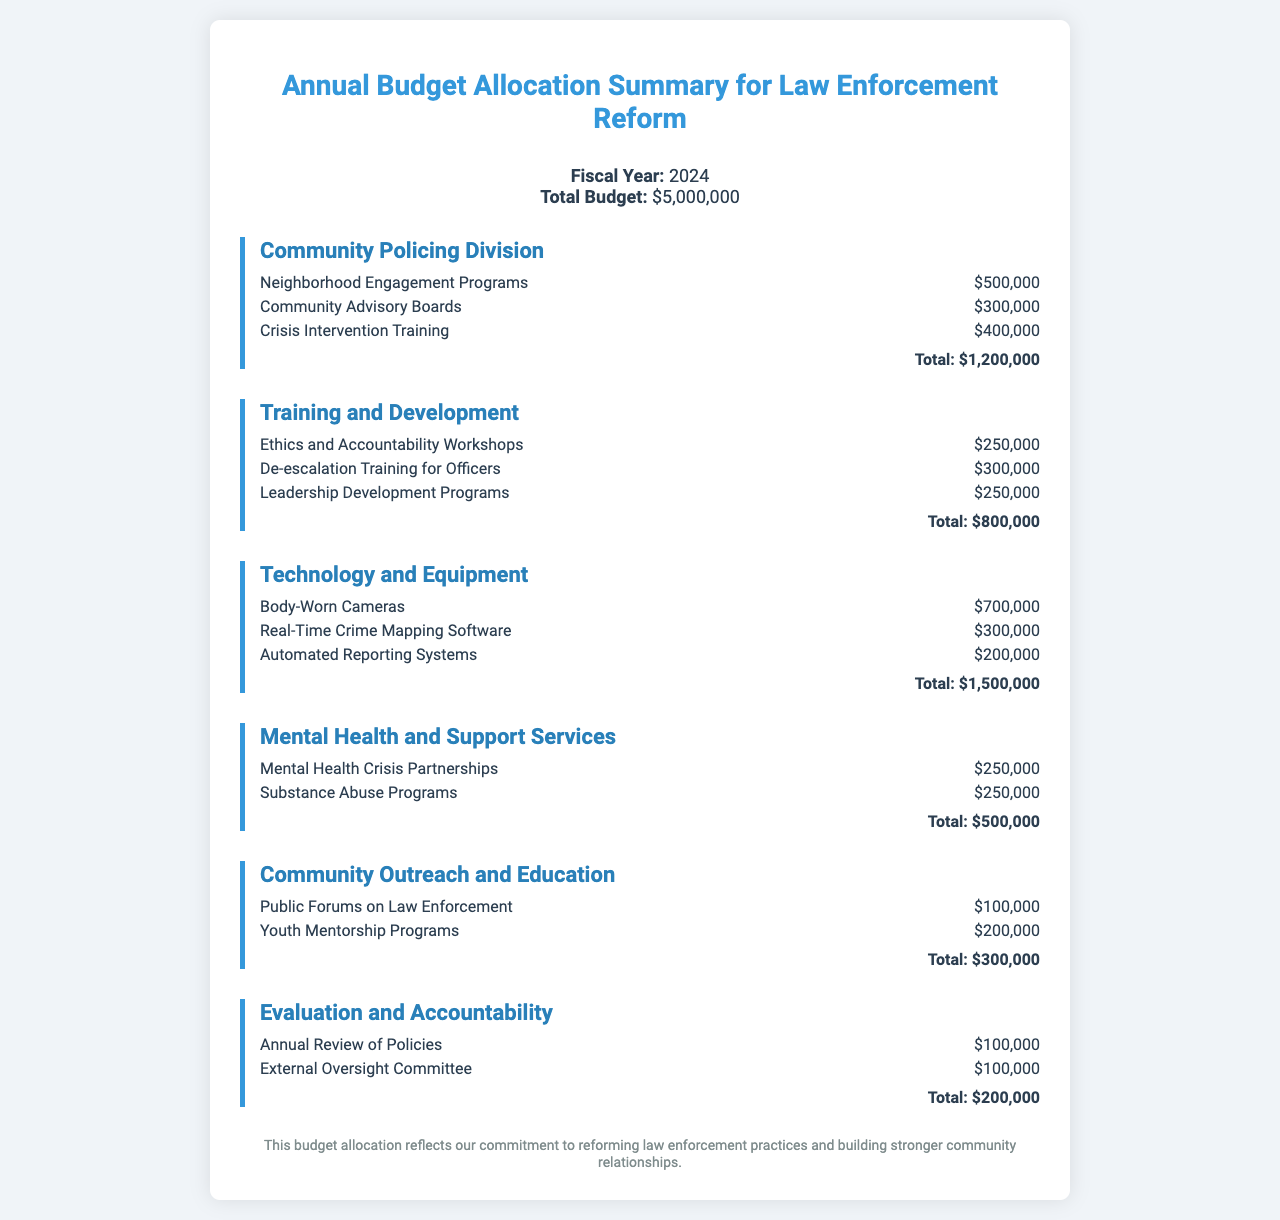What is the total budget for law enforcement reform? The total budget is stated clearly in the document as $5,000,000.
Answer: $5,000,000 How much is allocated for Neighborhood Engagement Programs? The allocation for Neighborhood Engagement Programs is specified in the Community Policing Division section as $500,000.
Answer: $500,000 What is the total allocated for Technology and Equipment? The total allocation for Technology and Equipment is the sum of all initiatives listed under that department, totaling $1,500,000.
Answer: $1,500,000 Which initiative has the highest budget in the Training and Development section? The initiative with the highest budget in the Training and Development section is De-escalation Training for Officers, which is $300,000.
Answer: De-escalation Training for Officers What is the combined budget for Mental Health and Support Services? The combined budget is the total for initiatives in the Mental Health and Support Services section, which sums to $500,000.
Answer: $500,000 How many initiatives are listed under Community Outreach and Education? The document states that there are two initiatives listed under Community Outreach and Education.
Answer: 2 What percentage of the total budget is allocated for Community Policing Division? The percentage is calculated by (1,200,000 / 5,000,000) * 100, which is 24%.
Answer: 24% What is the purpose of the Evaluation and Accountability department? The purpose is stated as ensuring the review of policies and external oversight, demonstrating commitment to reform.
Answer: Evaluation and Accountability How many total initiatives are listed in the document? The total number of initiatives is the sum of all initiatives across all departments, which is 12.
Answer: 12 